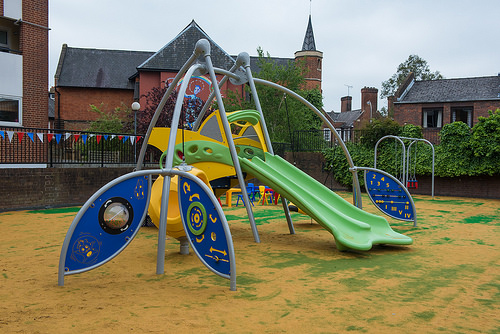<image>
Is there a slide behind the swings? No. The slide is not behind the swings. From this viewpoint, the slide appears to be positioned elsewhere in the scene. 